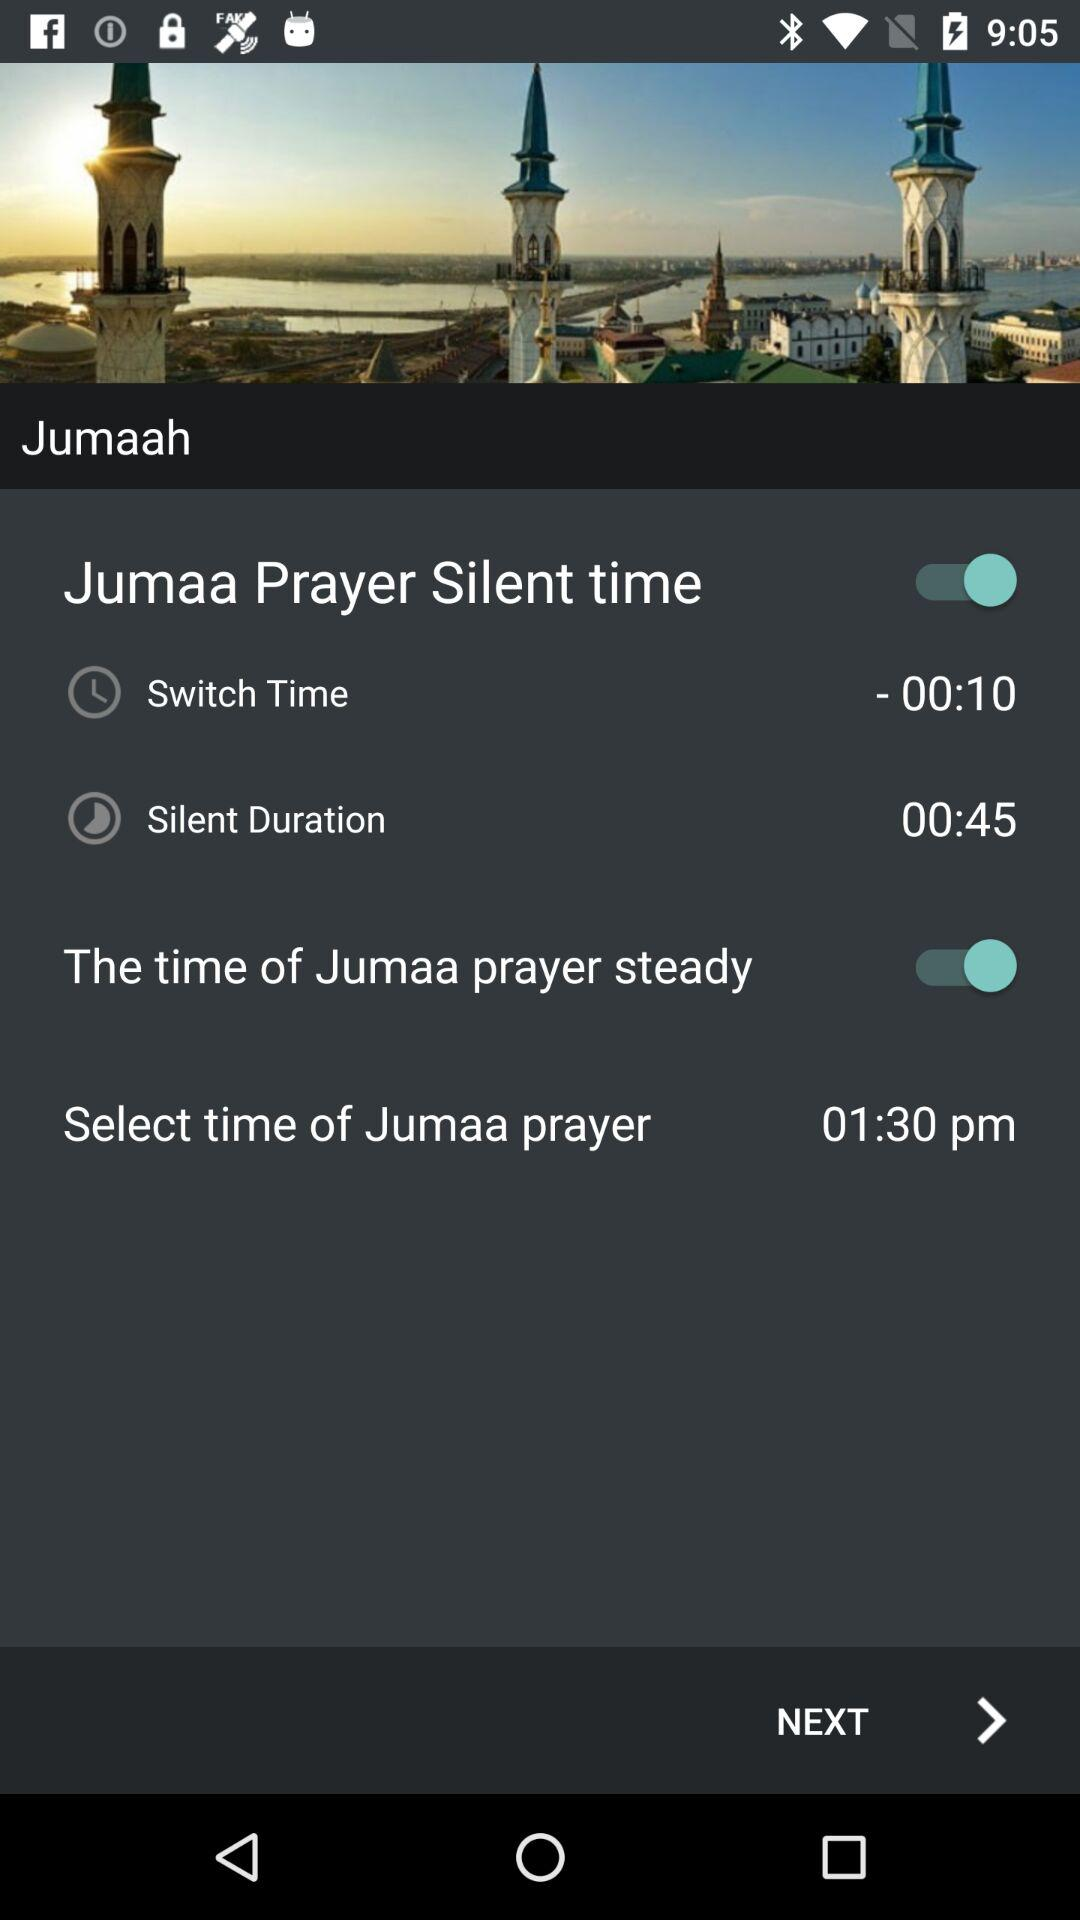How many more minutes is the silent duration than the switch time?
Answer the question using a single word or phrase. 35 